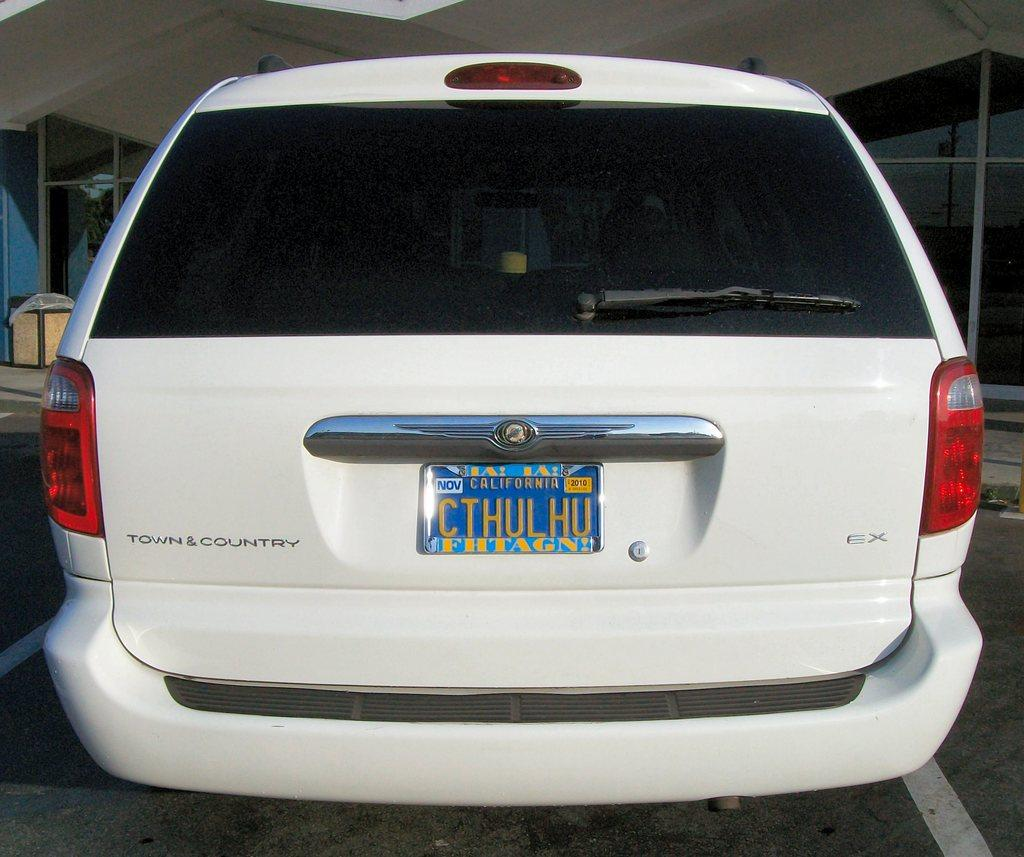What is the main subject of the image? The main subject of the image is a car. How many dogs are hooked to the car in the image? There are no dogs or hooks present in the image; it only features a car. 